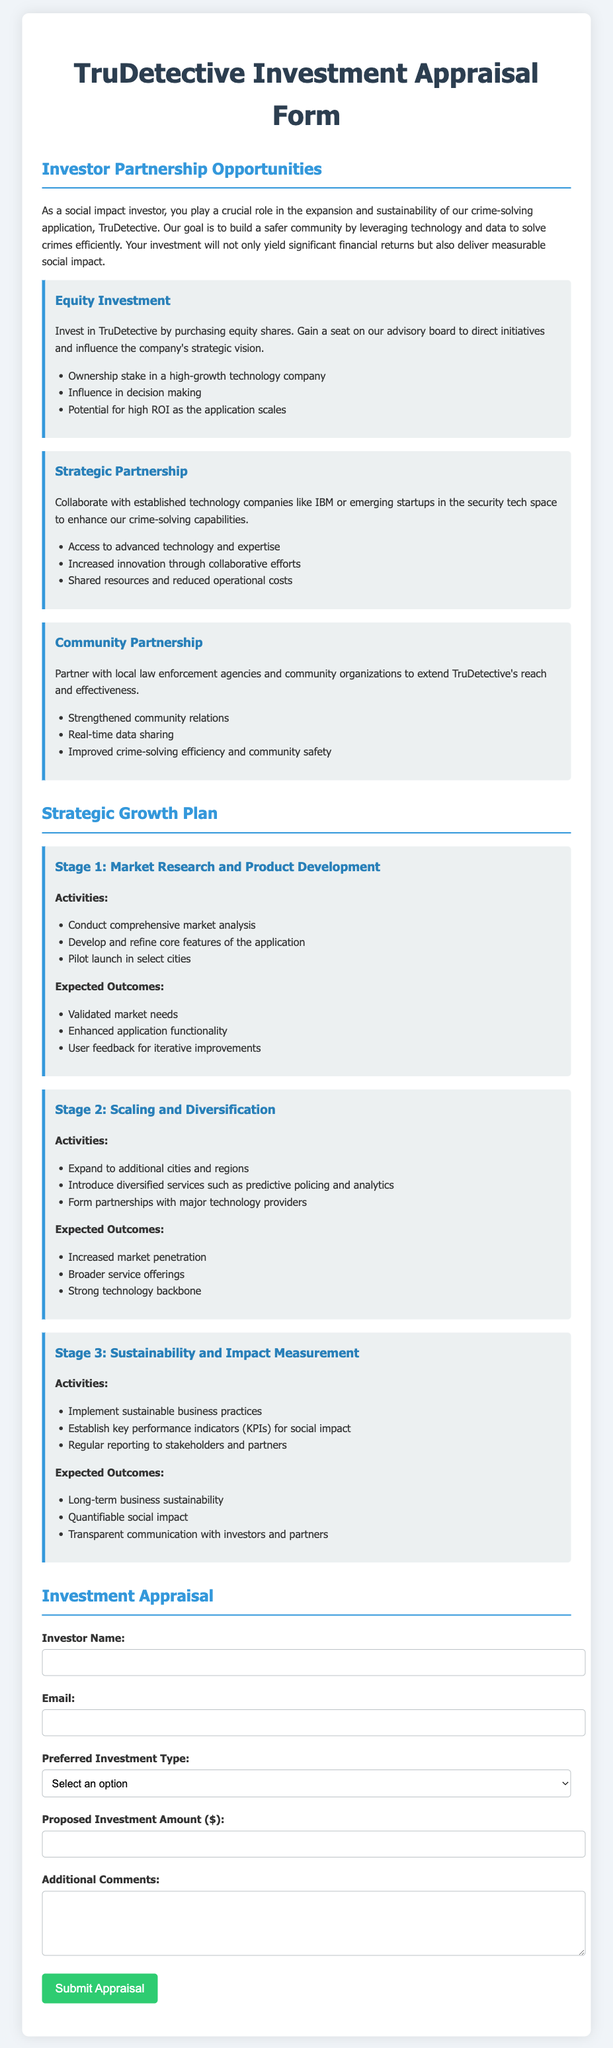What is the title of the document? The title is prominently displayed at the top of the document.
Answer: TruDetective Investment Appraisal Form What are the three investor partnership opportunities mentioned? The opportunities are listed under the section heading.
Answer: Equity Investment, Strategic Partnership, Community Partnership What is the expected outcome of Stage 1 in the Strategic Growth Plan? The expected outcomes are outlined in bullet points under each stage.
Answer: Validated market needs Which technology company is mentioned in the Strategic Partnership opportunity? This technology company is listed as a potential collaborator in the opportunity description.
Answer: IBM What is the proposed investment amount required in the form? This is a field that the investor must fill out in the form.
Answer: Proposed Investment Amount ($) What type of investment requires a seat on the advisory board? The type of investment that includes this benefit is specified in the description of one of the opportunities.
Answer: Equity Investment What is the main goal of TruDetective as mentioned in the document? This goal is stated in the introductory paragraph of the Investor Partnership Opportunities section.
Answer: Build a safer community How many stages are mentioned in the Strategic Growth Plan? This information can be counted from the headings in the document.
Answer: Three stages 